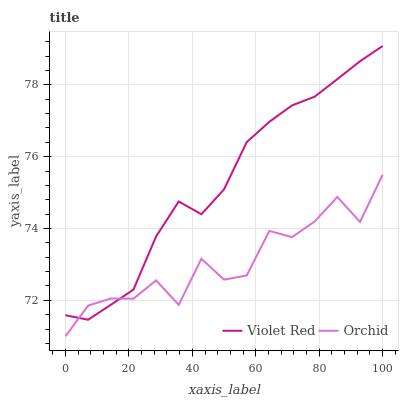Does Orchid have the minimum area under the curve?
Answer yes or no. Yes. Does Violet Red have the maximum area under the curve?
Answer yes or no. Yes. Does Orchid have the maximum area under the curve?
Answer yes or no. No. Is Violet Red the smoothest?
Answer yes or no. Yes. Is Orchid the roughest?
Answer yes or no. Yes. Is Orchid the smoothest?
Answer yes or no. No. Does Orchid have the lowest value?
Answer yes or no. Yes. Does Violet Red have the highest value?
Answer yes or no. Yes. Does Orchid have the highest value?
Answer yes or no. No. Does Violet Red intersect Orchid?
Answer yes or no. Yes. Is Violet Red less than Orchid?
Answer yes or no. No. Is Violet Red greater than Orchid?
Answer yes or no. No. 